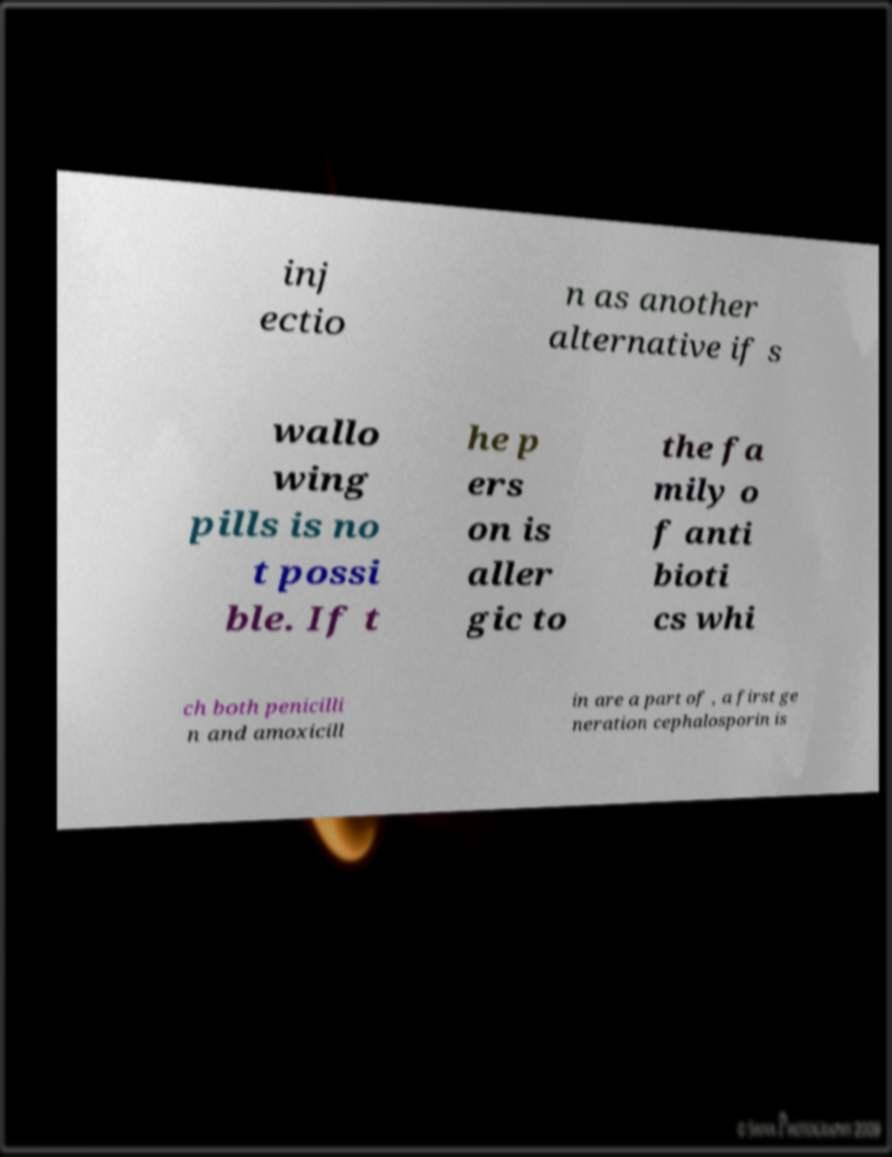Could you extract and type out the text from this image? inj ectio n as another alternative if s wallo wing pills is no t possi ble. If t he p ers on is aller gic to the fa mily o f anti bioti cs whi ch both penicilli n and amoxicill in are a part of , a first ge neration cephalosporin is 